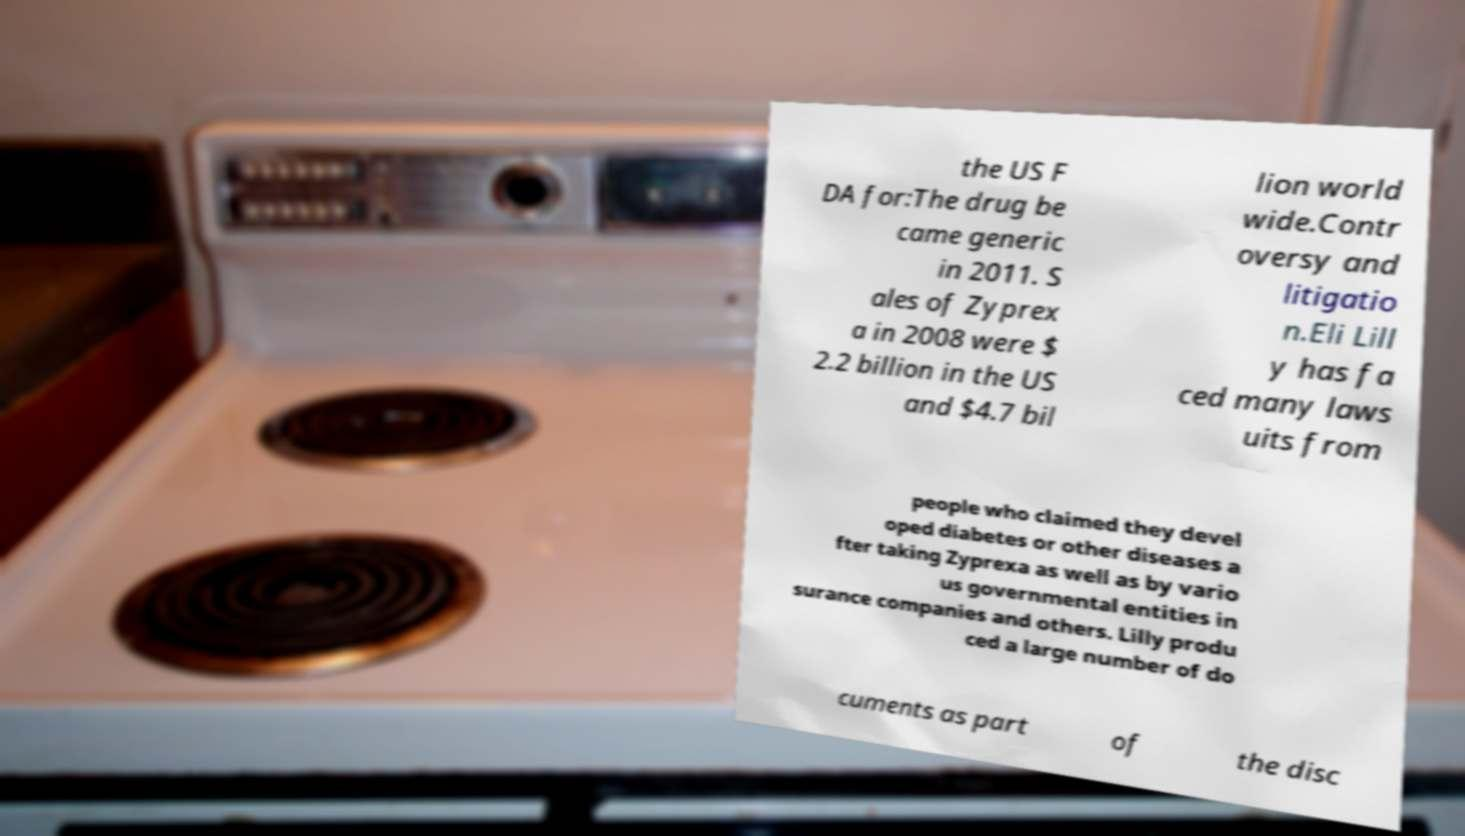For documentation purposes, I need the text within this image transcribed. Could you provide that? the US F DA for:The drug be came generic in 2011. S ales of Zyprex a in 2008 were $ 2.2 billion in the US and $4.7 bil lion world wide.Contr oversy and litigatio n.Eli Lill y has fa ced many laws uits from people who claimed they devel oped diabetes or other diseases a fter taking Zyprexa as well as by vario us governmental entities in surance companies and others. Lilly produ ced a large number of do cuments as part of the disc 